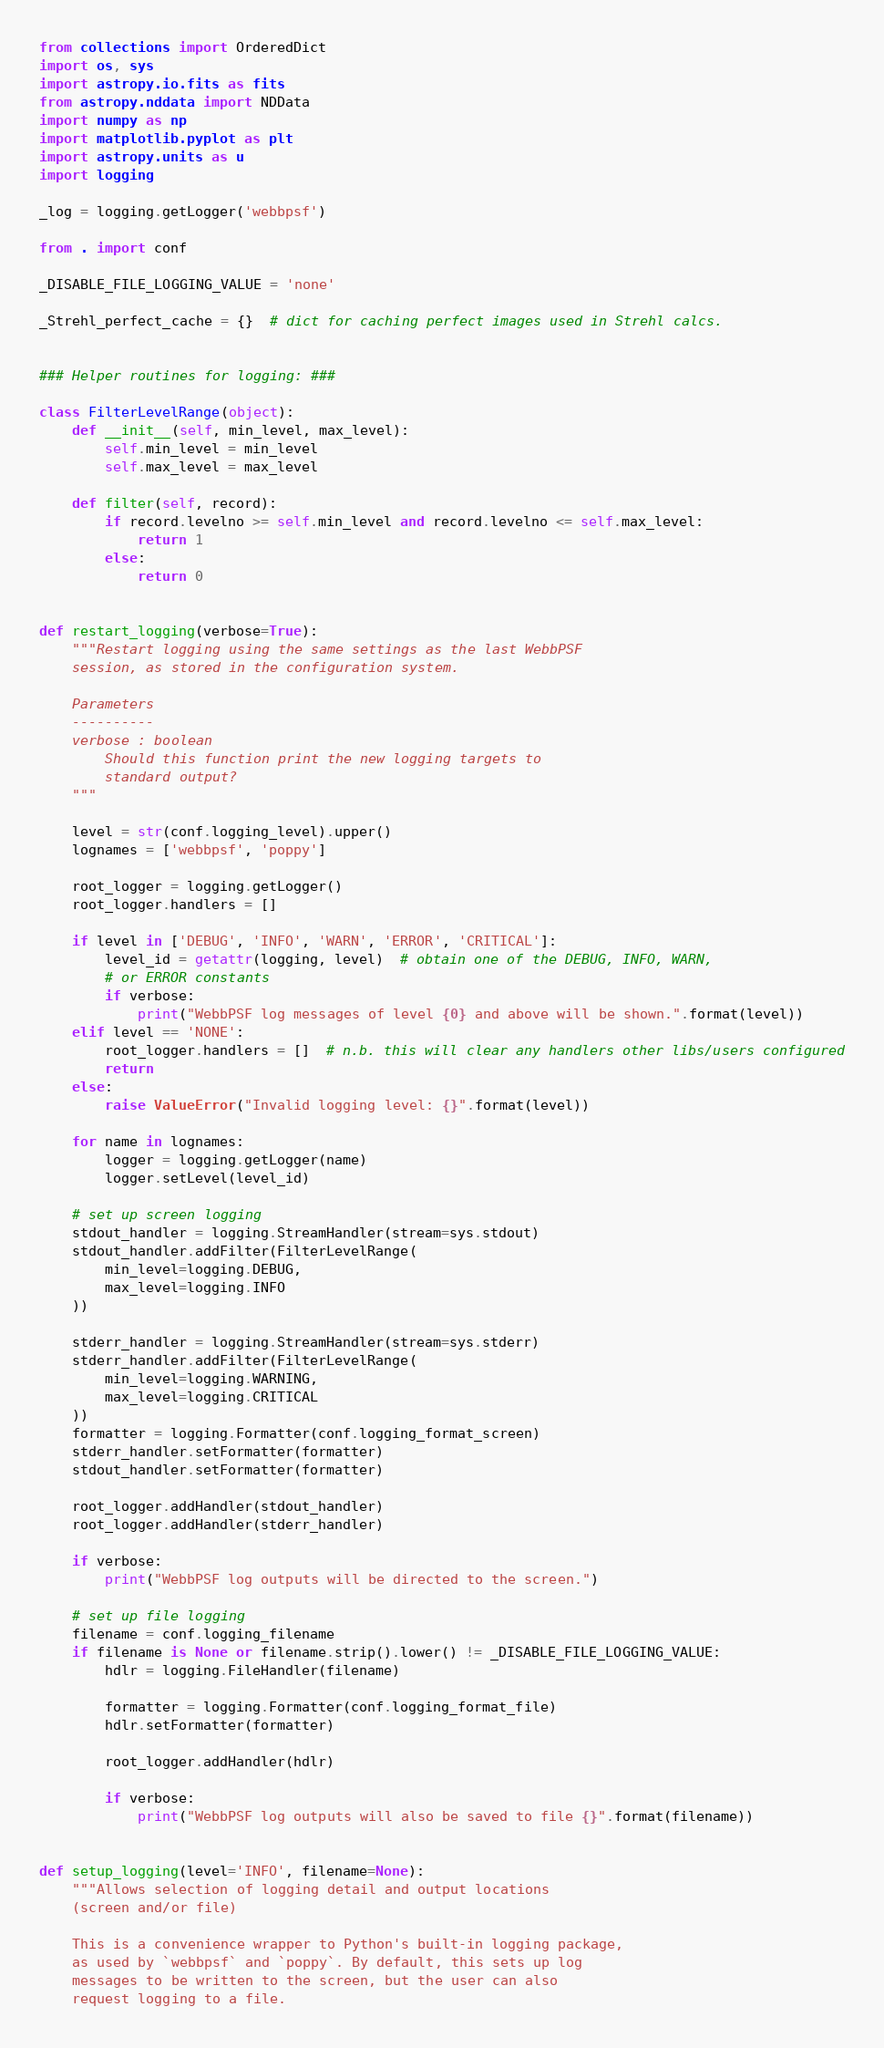<code> <loc_0><loc_0><loc_500><loc_500><_Python_>from collections import OrderedDict
import os, sys
import astropy.io.fits as fits
from astropy.nddata import NDData
import numpy as np
import matplotlib.pyplot as plt
import astropy.units as u
import logging

_log = logging.getLogger('webbpsf')

from . import conf

_DISABLE_FILE_LOGGING_VALUE = 'none'

_Strehl_perfect_cache = {}  # dict for caching perfect images used in Strehl calcs.


### Helper routines for logging: ###

class FilterLevelRange(object):
    def __init__(self, min_level, max_level):
        self.min_level = min_level
        self.max_level = max_level

    def filter(self, record):
        if record.levelno >= self.min_level and record.levelno <= self.max_level:
            return 1
        else:
            return 0


def restart_logging(verbose=True):
    """Restart logging using the same settings as the last WebbPSF
    session, as stored in the configuration system.

    Parameters
    ----------
    verbose : boolean
        Should this function print the new logging targets to
        standard output?
    """

    level = str(conf.logging_level).upper()
    lognames = ['webbpsf', 'poppy']

    root_logger = logging.getLogger()
    root_logger.handlers = []

    if level in ['DEBUG', 'INFO', 'WARN', 'ERROR', 'CRITICAL']:
        level_id = getattr(logging, level)  # obtain one of the DEBUG, INFO, WARN,
        # or ERROR constants
        if verbose:
            print("WebbPSF log messages of level {0} and above will be shown.".format(level))
    elif level == 'NONE':
        root_logger.handlers = []  # n.b. this will clear any handlers other libs/users configured
        return
    else:
        raise ValueError("Invalid logging level: {}".format(level))

    for name in lognames:
        logger = logging.getLogger(name)
        logger.setLevel(level_id)

    # set up screen logging
    stdout_handler = logging.StreamHandler(stream=sys.stdout)
    stdout_handler.addFilter(FilterLevelRange(
        min_level=logging.DEBUG,
        max_level=logging.INFO
    ))

    stderr_handler = logging.StreamHandler(stream=sys.stderr)
    stderr_handler.addFilter(FilterLevelRange(
        min_level=logging.WARNING,
        max_level=logging.CRITICAL
    ))
    formatter = logging.Formatter(conf.logging_format_screen)
    stderr_handler.setFormatter(formatter)
    stdout_handler.setFormatter(formatter)

    root_logger.addHandler(stdout_handler)
    root_logger.addHandler(stderr_handler)

    if verbose:
        print("WebbPSF log outputs will be directed to the screen.")

    # set up file logging
    filename = conf.logging_filename
    if filename is None or filename.strip().lower() != _DISABLE_FILE_LOGGING_VALUE:
        hdlr = logging.FileHandler(filename)

        formatter = logging.Formatter(conf.logging_format_file)
        hdlr.setFormatter(formatter)

        root_logger.addHandler(hdlr)

        if verbose:
            print("WebbPSF log outputs will also be saved to file {}".format(filename))


def setup_logging(level='INFO', filename=None):
    """Allows selection of logging detail and output locations
    (screen and/or file)

    This is a convenience wrapper to Python's built-in logging package,
    as used by `webbpsf` and `poppy`. By default, this sets up log
    messages to be written to the screen, but the user can also
    request logging to a file.
</code> 